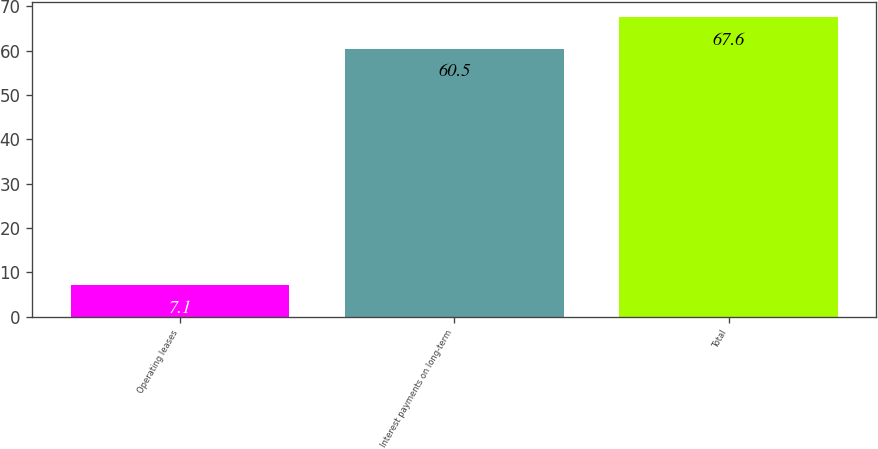<chart> <loc_0><loc_0><loc_500><loc_500><bar_chart><fcel>Operating leases<fcel>Interest payments on long-term<fcel>Total<nl><fcel>7.1<fcel>60.5<fcel>67.6<nl></chart> 